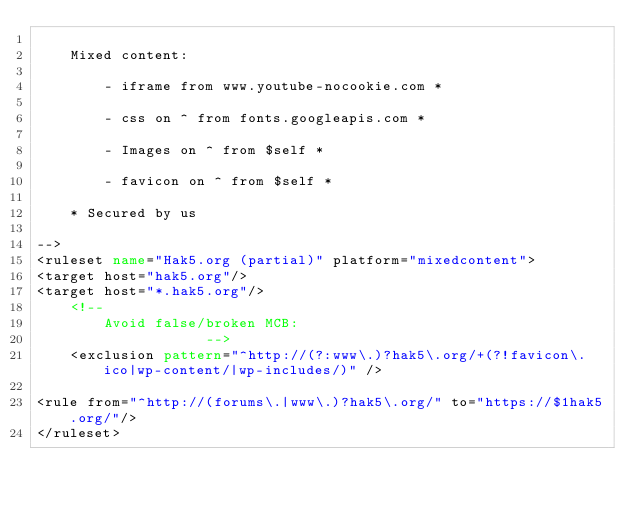Convert code to text. <code><loc_0><loc_0><loc_500><loc_500><_XML_>
	Mixed content:

		- iframe from www.youtube-nocookie.com *

		- css on ^ from fonts.googleapis.com *

		- Images on ^ from $self *

		- favicon on ^ from $self *

	* Secured by us

-->
<ruleset name="Hak5.org (partial)" platform="mixedcontent">
<target host="hak5.org"/>
<target host="*.hak5.org"/>
	<!--
		Avoid false/broken MCB:
					-->
	<exclusion pattern="^http://(?:www\.)?hak5\.org/+(?!favicon\.ico|wp-content/|wp-includes/)" />

<rule from="^http://(forums\.|www\.)?hak5\.org/" to="https://$1hak5.org/"/>
</ruleset>
</code> 